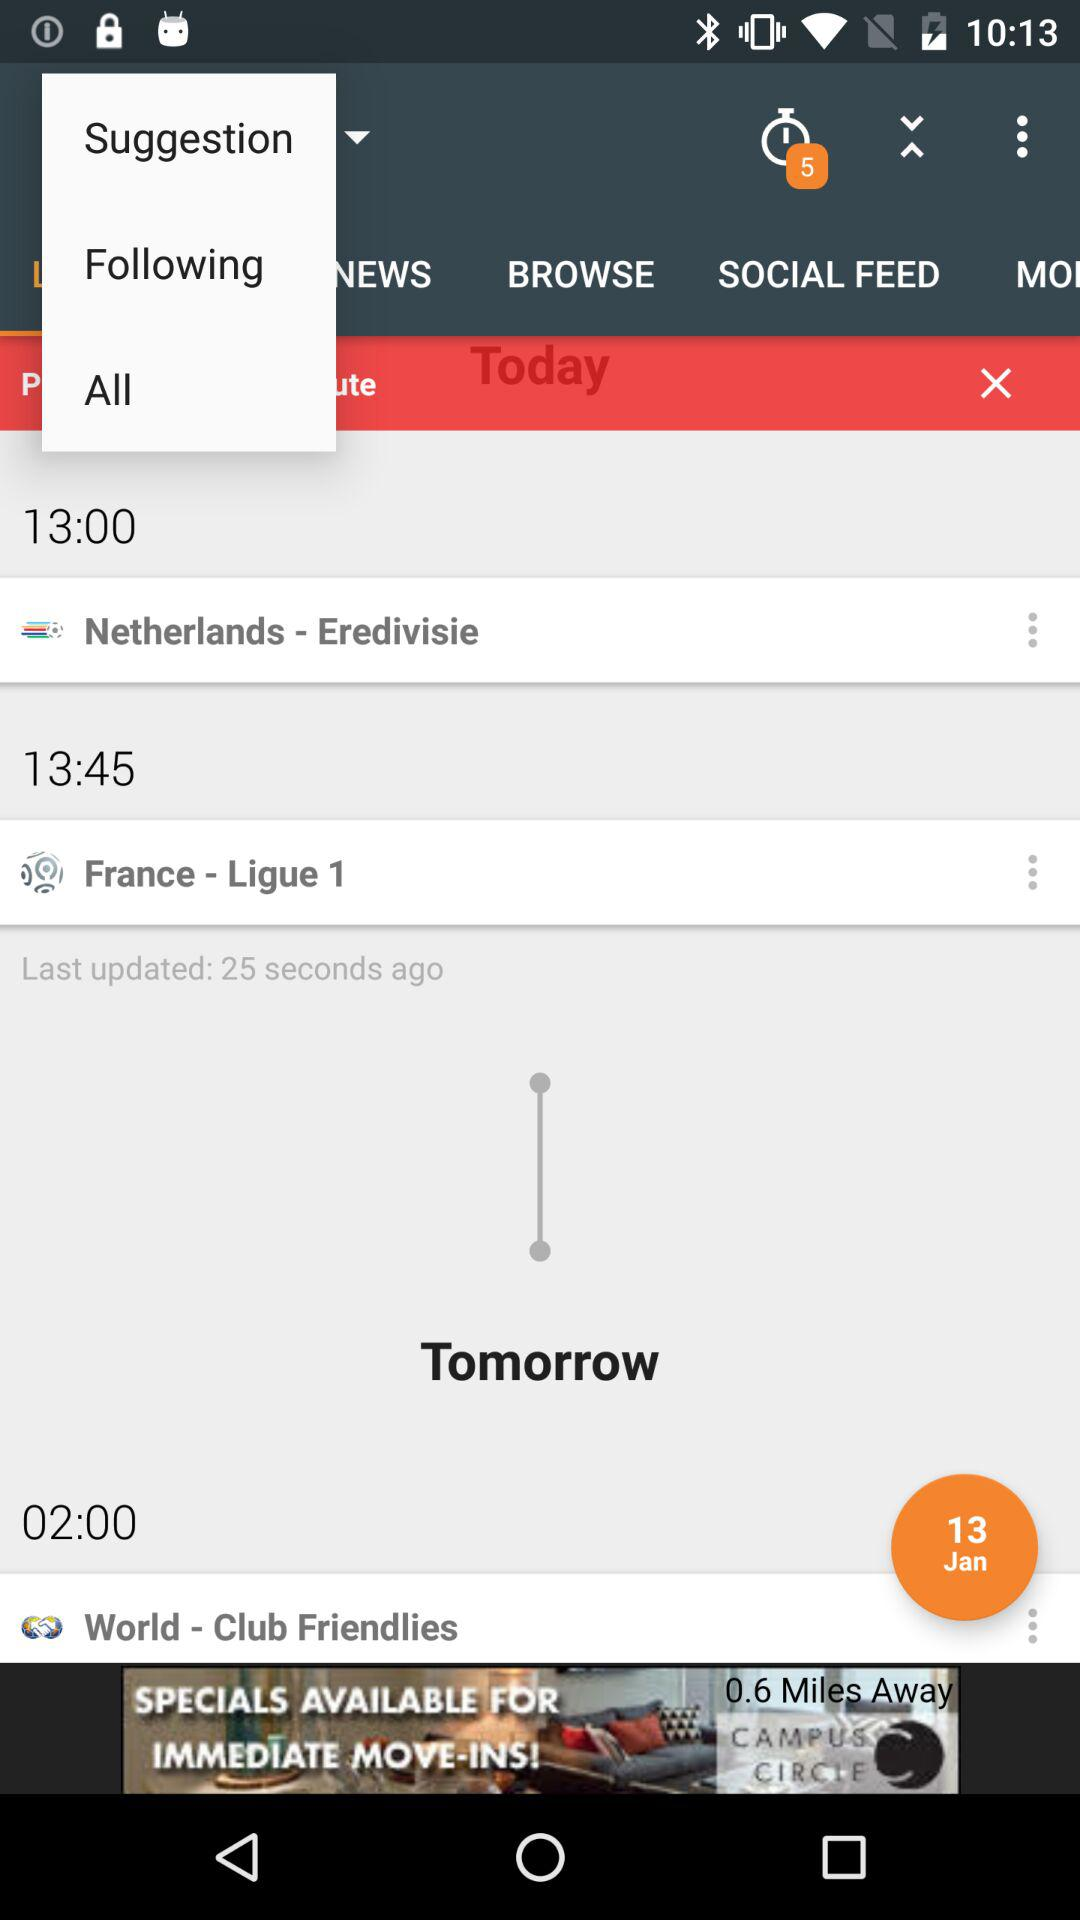What is the location at 13:45? The location is "France". 